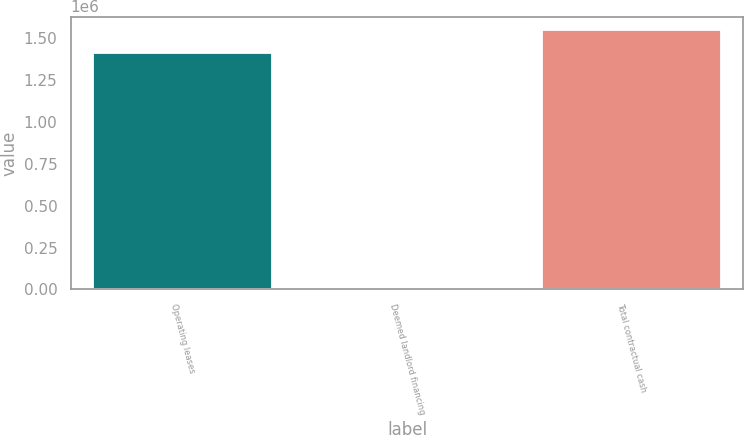Convert chart to OTSL. <chart><loc_0><loc_0><loc_500><loc_500><bar_chart><fcel>Operating leases<fcel>Deemed landlord financing<fcel>Total contractual cash<nl><fcel>1.41057e+06<fcel>7395<fcel>1.55285e+06<nl></chart> 